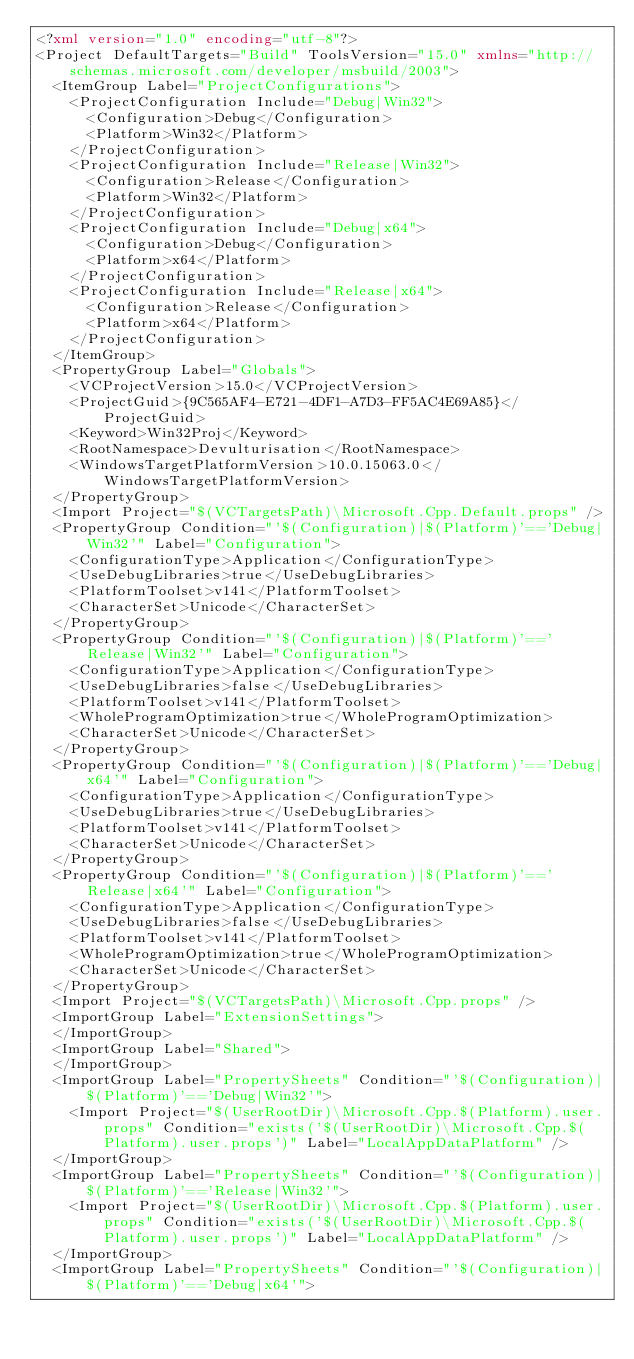Convert code to text. <code><loc_0><loc_0><loc_500><loc_500><_XML_><?xml version="1.0" encoding="utf-8"?>
<Project DefaultTargets="Build" ToolsVersion="15.0" xmlns="http://schemas.microsoft.com/developer/msbuild/2003">
  <ItemGroup Label="ProjectConfigurations">
    <ProjectConfiguration Include="Debug|Win32">
      <Configuration>Debug</Configuration>
      <Platform>Win32</Platform>
    </ProjectConfiguration>
    <ProjectConfiguration Include="Release|Win32">
      <Configuration>Release</Configuration>
      <Platform>Win32</Platform>
    </ProjectConfiguration>
    <ProjectConfiguration Include="Debug|x64">
      <Configuration>Debug</Configuration>
      <Platform>x64</Platform>
    </ProjectConfiguration>
    <ProjectConfiguration Include="Release|x64">
      <Configuration>Release</Configuration>
      <Platform>x64</Platform>
    </ProjectConfiguration>
  </ItemGroup>
  <PropertyGroup Label="Globals">
    <VCProjectVersion>15.0</VCProjectVersion>
    <ProjectGuid>{9C565AF4-E721-4DF1-A7D3-FF5AC4E69A85}</ProjectGuid>
    <Keyword>Win32Proj</Keyword>
    <RootNamespace>Devulturisation</RootNamespace>
    <WindowsTargetPlatformVersion>10.0.15063.0</WindowsTargetPlatformVersion>
  </PropertyGroup>
  <Import Project="$(VCTargetsPath)\Microsoft.Cpp.Default.props" />
  <PropertyGroup Condition="'$(Configuration)|$(Platform)'=='Debug|Win32'" Label="Configuration">
    <ConfigurationType>Application</ConfigurationType>
    <UseDebugLibraries>true</UseDebugLibraries>
    <PlatformToolset>v141</PlatformToolset>
    <CharacterSet>Unicode</CharacterSet>
  </PropertyGroup>
  <PropertyGroup Condition="'$(Configuration)|$(Platform)'=='Release|Win32'" Label="Configuration">
    <ConfigurationType>Application</ConfigurationType>
    <UseDebugLibraries>false</UseDebugLibraries>
    <PlatformToolset>v141</PlatformToolset>
    <WholeProgramOptimization>true</WholeProgramOptimization>
    <CharacterSet>Unicode</CharacterSet>
  </PropertyGroup>
  <PropertyGroup Condition="'$(Configuration)|$(Platform)'=='Debug|x64'" Label="Configuration">
    <ConfigurationType>Application</ConfigurationType>
    <UseDebugLibraries>true</UseDebugLibraries>
    <PlatformToolset>v141</PlatformToolset>
    <CharacterSet>Unicode</CharacterSet>
  </PropertyGroup>
  <PropertyGroup Condition="'$(Configuration)|$(Platform)'=='Release|x64'" Label="Configuration">
    <ConfigurationType>Application</ConfigurationType>
    <UseDebugLibraries>false</UseDebugLibraries>
    <PlatformToolset>v141</PlatformToolset>
    <WholeProgramOptimization>true</WholeProgramOptimization>
    <CharacterSet>Unicode</CharacterSet>
  </PropertyGroup>
  <Import Project="$(VCTargetsPath)\Microsoft.Cpp.props" />
  <ImportGroup Label="ExtensionSettings">
  </ImportGroup>
  <ImportGroup Label="Shared">
  </ImportGroup>
  <ImportGroup Label="PropertySheets" Condition="'$(Configuration)|$(Platform)'=='Debug|Win32'">
    <Import Project="$(UserRootDir)\Microsoft.Cpp.$(Platform).user.props" Condition="exists('$(UserRootDir)\Microsoft.Cpp.$(Platform).user.props')" Label="LocalAppDataPlatform" />
  </ImportGroup>
  <ImportGroup Label="PropertySheets" Condition="'$(Configuration)|$(Platform)'=='Release|Win32'">
    <Import Project="$(UserRootDir)\Microsoft.Cpp.$(Platform).user.props" Condition="exists('$(UserRootDir)\Microsoft.Cpp.$(Platform).user.props')" Label="LocalAppDataPlatform" />
  </ImportGroup>
  <ImportGroup Label="PropertySheets" Condition="'$(Configuration)|$(Platform)'=='Debug|x64'"></code> 